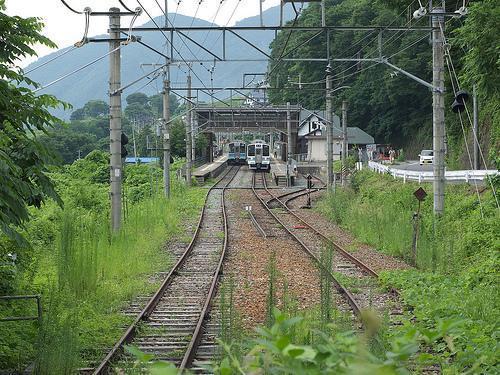How many trains are on the tracks?
Give a very brief answer. 2. How many rails are in the picture?
Give a very brief answer. 2. How many trains are visible?
Give a very brief answer. 2. 